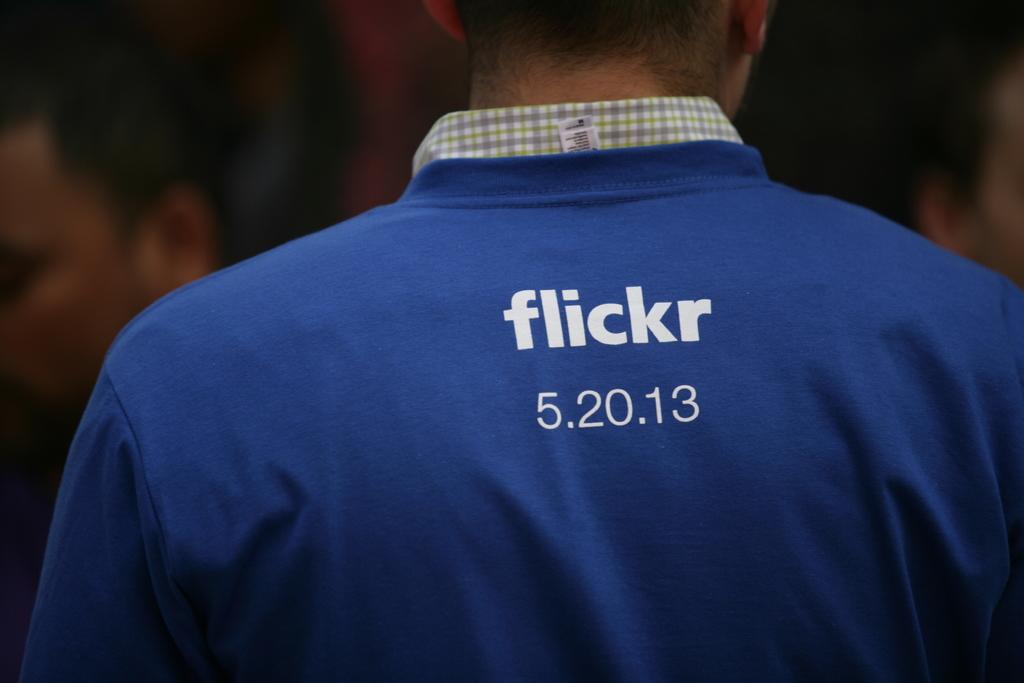Whats the team?
Offer a very short reply. Flickr. 